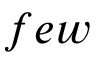<formula> <loc_0><loc_0><loc_500><loc_500>f e w</formula> 